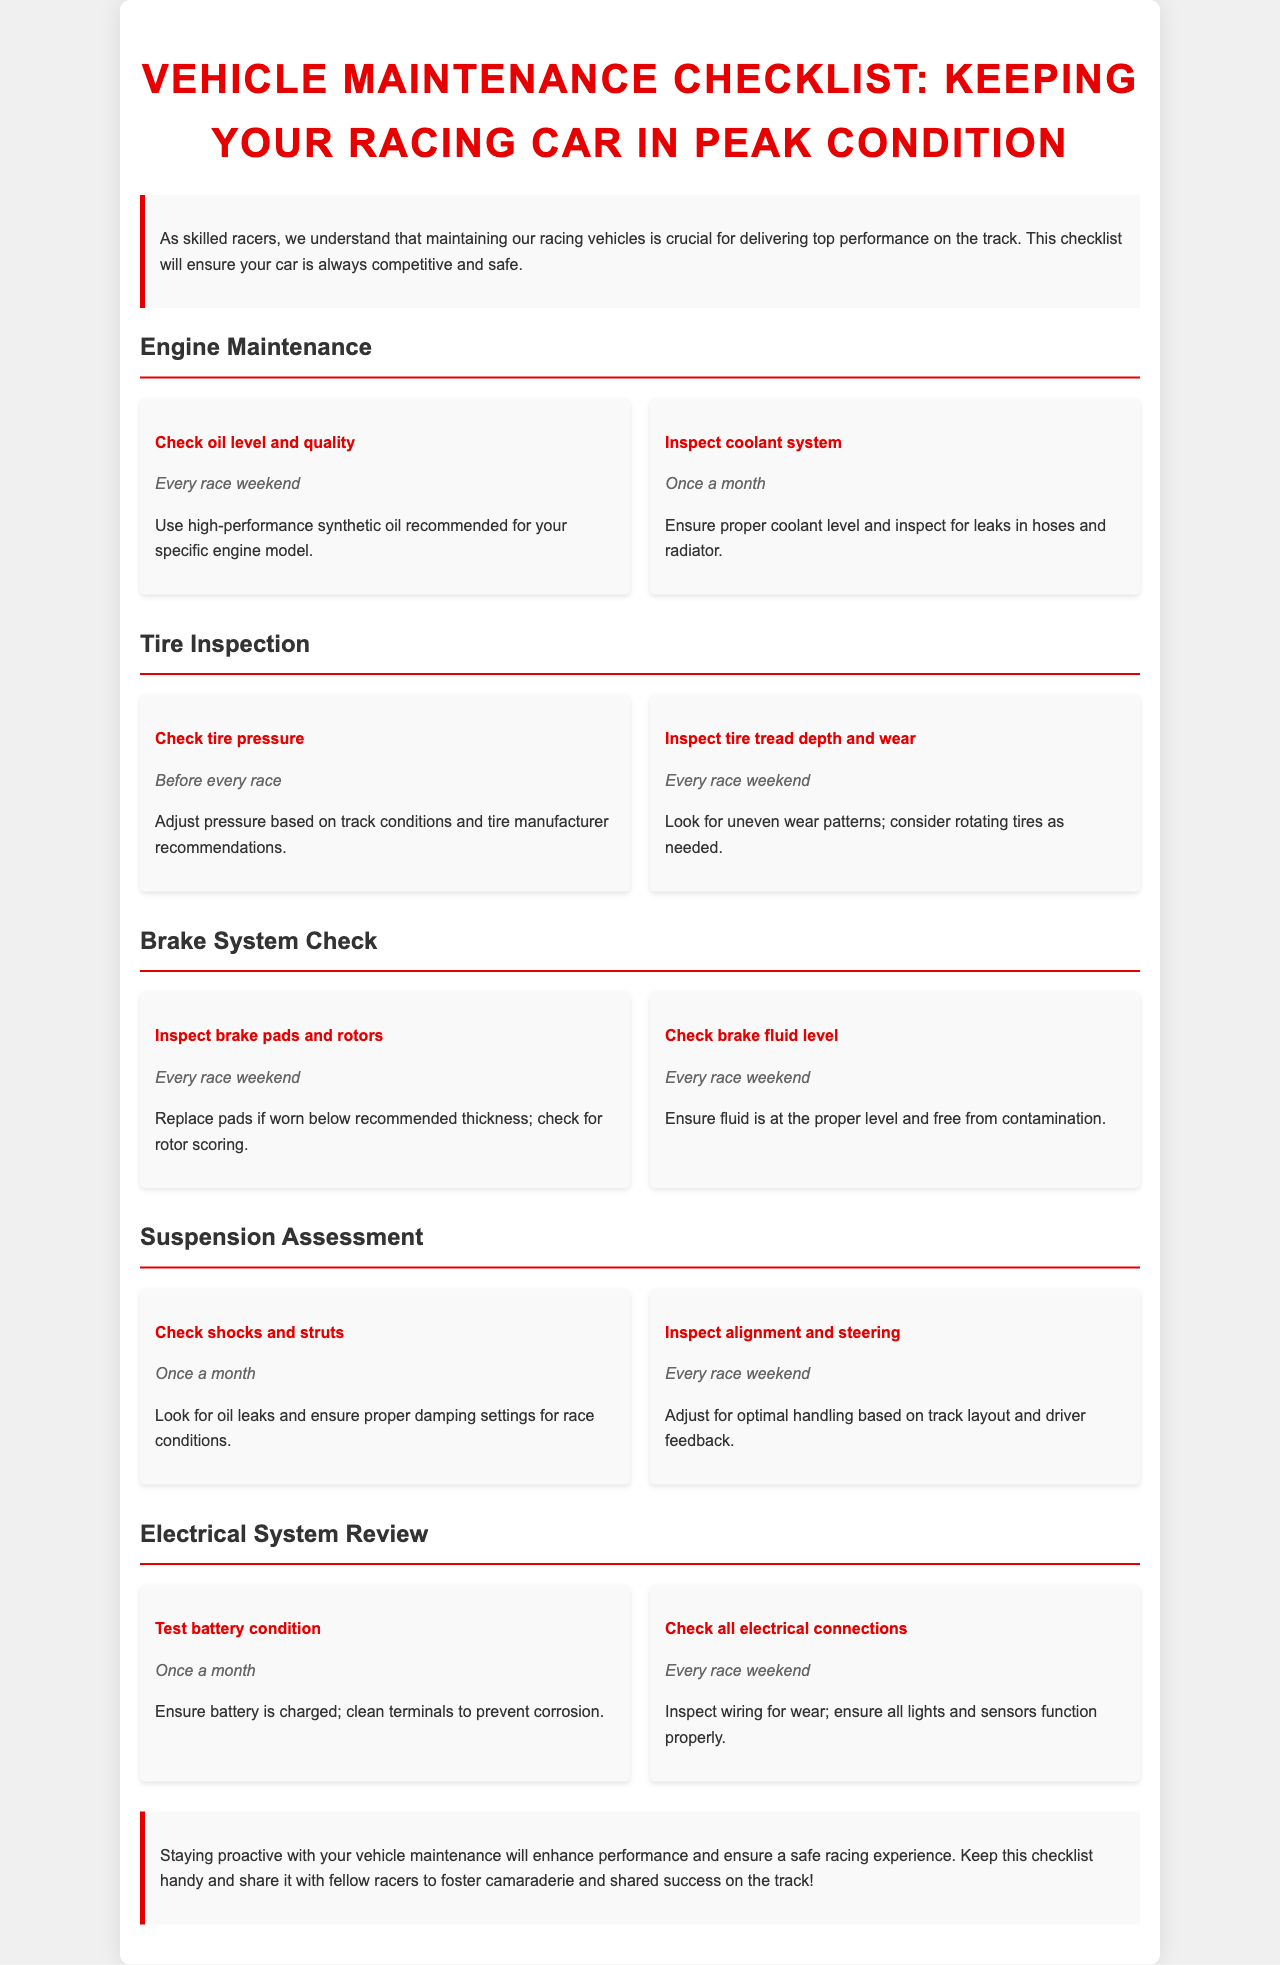What is the main focus of the brochure? The main focus is on maintaining racing vehicles for peak performance and safety.
Answer: Maintaining racing vehicles How often should you check oil level and quality? The document states that oil level and quality should be checked every race weekend.
Answer: Every race weekend What should you inspect once a month related to the suspension? The shocks and struts should be checked once a month.
Answer: Shocks and struts What is recommended for the coolant system inspection? It is recommended to ensure proper coolant level and inspect for leaks.
Answer: Proper coolant level and inspect for leaks How frequently should tire pressure be checked? Tire pressure should be checked before every race.
Answer: Before every race What indicates that brake pads need replacement? Brake pads need replacement if worn below recommended thickness.
Answer: Worn below recommended thickness What is the frequency for checking battery condition? Battery condition should be checked once a month.
Answer: Once a month What should be inspected for wear related to the electrical system? The wiring should be inspected for wear.
Answer: Wiring What is one benefit of staying proactive with vehicle maintenance? Enhancing performance is a benefit of proactive maintenance.
Answer: Enhancing performance 